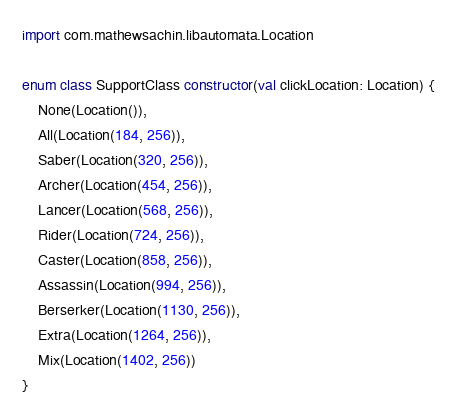<code> <loc_0><loc_0><loc_500><loc_500><_Kotlin_>import com.mathewsachin.libautomata.Location

enum class SupportClass constructor(val clickLocation: Location) {
    None(Location()),
    All(Location(184, 256)),
    Saber(Location(320, 256)),
    Archer(Location(454, 256)),
    Lancer(Location(568, 256)),
    Rider(Location(724, 256)),
    Caster(Location(858, 256)),
    Assassin(Location(994, 256)),
    Berserker(Location(1130, 256)),
    Extra(Location(1264, 256)),
    Mix(Location(1402, 256))
}</code> 